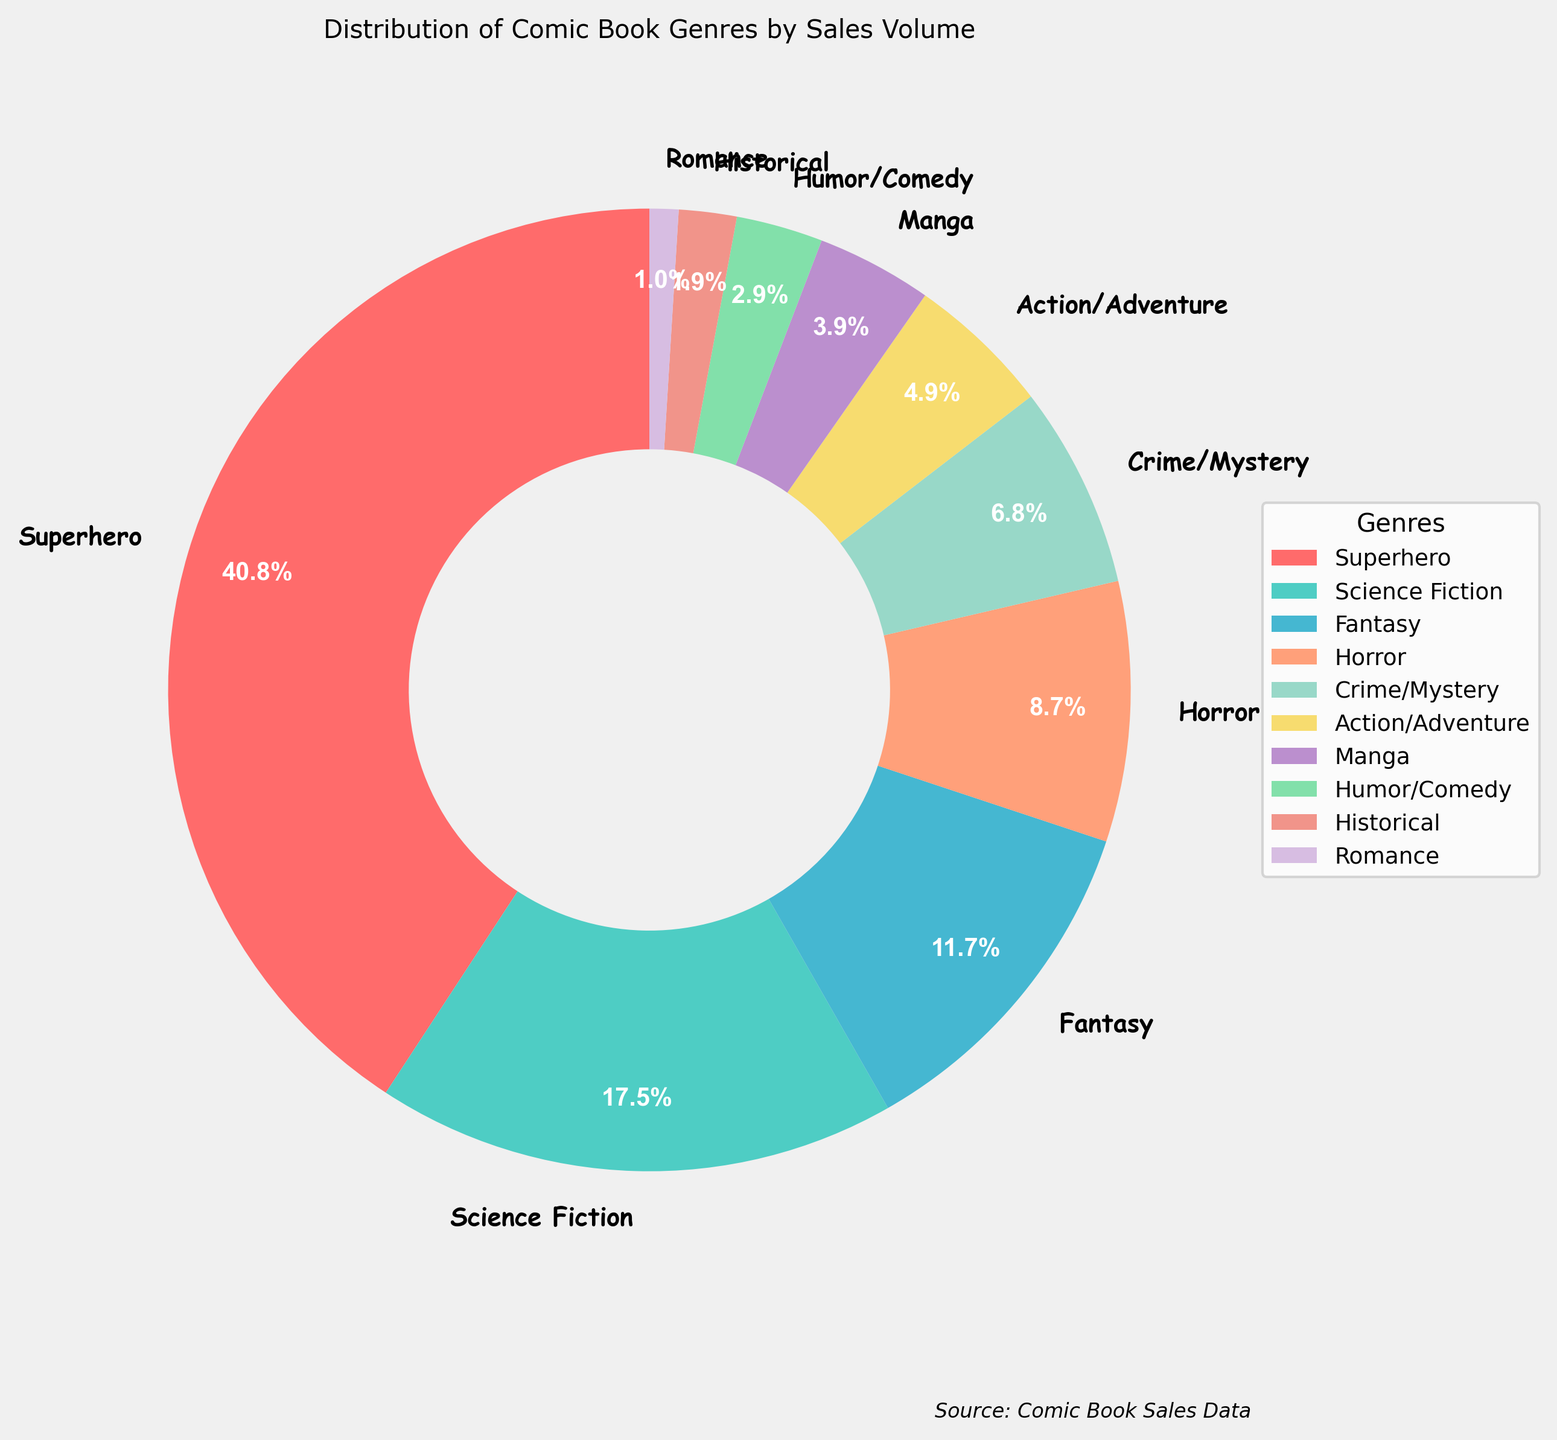What's the least popular comic book genre based on sales volume? To find the least popular genre, look for the smallest percentage slice in the pie chart. Romance has the smallest slice.
Answer: Romance Which genre has a larger sales volume, Fantasy or Horror? Compare the sizes of the slices for Fantasy and Horror. Fantasy has 12% and Horror has 9%. Fantasy is larger.
Answer: Fantasy What is the combined sales volume percentage of Science Fiction and Action/Adventure? Add the percentages of Science Fiction and Action/Adventure. Science Fiction is 18% and Action/Adventure is 5%. 18% + 5% = 23%.
Answer: 23% Which two genres combined make up exactly 10% of the sales volume? Identify two slices whose percentages add to 10%. Crime/Mystery (7%) and Romance (1%) add up to 10%.
Answer: Crime/Mystery and Romance How does the sales volume of Crime/Mystery compare to that of Manga? Compare the sizes of the Crime/Mystery and Manga slices. Crime/Mystery is 7% and Manga is 4%. Crime/Mystery is larger.
Answer: Crime/Mystery Which genre has the third largest sales volume? The third largest slice represents the third largest sales volume. Fantasy with 12% is the third largest.
Answer: Fantasy What is the average sales volume percentage of Superhero, Science Fiction, and Horror genres? Calculate the sum of percentages for Superhero, Science Fiction, and Horror, then divide by 3. (42% + 18% + 9%) / 3 = 69% / 3 = 23%.
Answer: 23% Which genres have a sales volume higher than Historical? Compare the slices to Historical (2%), and list those greater. Superhero, Science Fiction, Fantasy, Horror, Crime/Mystery, Action/Adventure, Manga, and Humor/Comedy are all greater than Historical.
Answer: 8 genres What's the difference in sales volume between the most and the least popular genres? Subtract the percentage of the least popular genre (Romance 1%) from the most popular genre (Superhero 42%). 42% - 1% = 41%.
Answer: 41% Which genre contributes the second lowest sales volume? Identify the second smallest slice after Romance. The second smallest slice is Historical at 2%.
Answer: Historical 